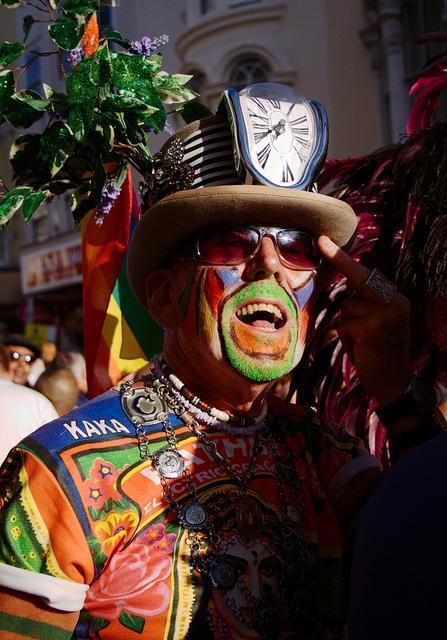How many people are there?
Give a very brief answer. 2. How many of the people sitting have a laptop on there lap?
Give a very brief answer. 0. 